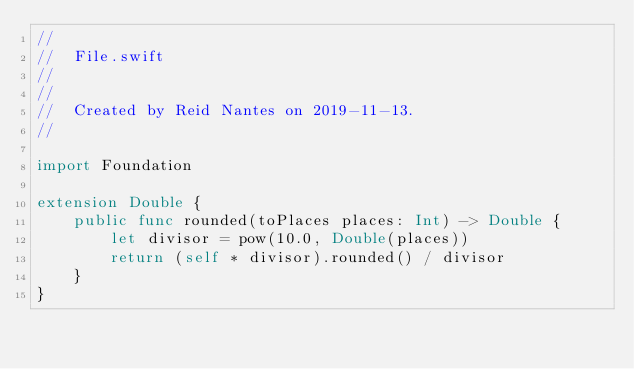Convert code to text. <code><loc_0><loc_0><loc_500><loc_500><_Swift_>//
//  File.swift
//  
//
//  Created by Reid Nantes on 2019-11-13.
//

import Foundation

extension Double {
    public func rounded(toPlaces places: Int) -> Double {
        let divisor = pow(10.0, Double(places))
        return (self * divisor).rounded() / divisor
    }
}
</code> 